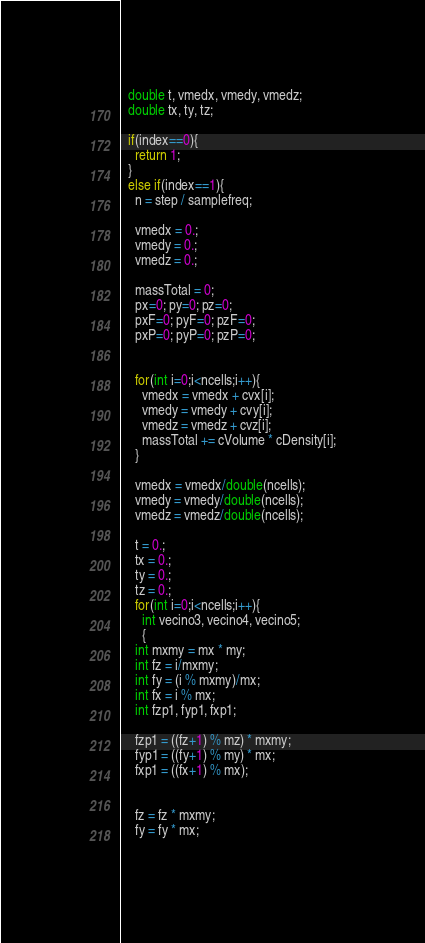Convert code to text. <code><loc_0><loc_0><loc_500><loc_500><_Cuda_>  double t, vmedx, vmedy, vmedz;
  double tx, ty, tz;
  
  if(index==0){
    return 1;
  }
  else if(index==1){
    n = step / samplefreq;
    
    vmedx = 0.;
    vmedy = 0.;
    vmedz = 0.;
    
    massTotal = 0;
    px=0; py=0; pz=0;
    pxF=0; pyF=0; pzF=0;
    pxP=0; pyP=0; pzP=0;
    
    
    for(int i=0;i<ncells;i++){
      vmedx = vmedx + cvx[i]; 
      vmedy = vmedy + cvy[i];
      vmedz = vmedz + cvz[i];
      massTotal += cVolume * cDensity[i];
    }
    
    vmedx = vmedx/double(ncells);
    vmedy = vmedy/double(ncells);
    vmedz = vmedz/double(ncells);
    
    t = 0.;
    tx = 0.;
    ty = 0.;
    tz = 0.;
    for(int i=0;i<ncells;i++){
      int vecino3, vecino4, vecino5; 
      {
	int mxmy = mx * my;
	int fz = i/mxmy;
	int fy = (i % mxmy)/mx;
	int fx = i % mx;
	int fzp1, fyp1, fxp1;
	
	fzp1 = ((fz+1) % mz) * mxmy;
	fyp1 = ((fy+1) % my) * mx;
	fxp1 = ((fx+1) % mx);
	
	
	fz = fz * mxmy;
	fy = fy * mx;
	</code> 